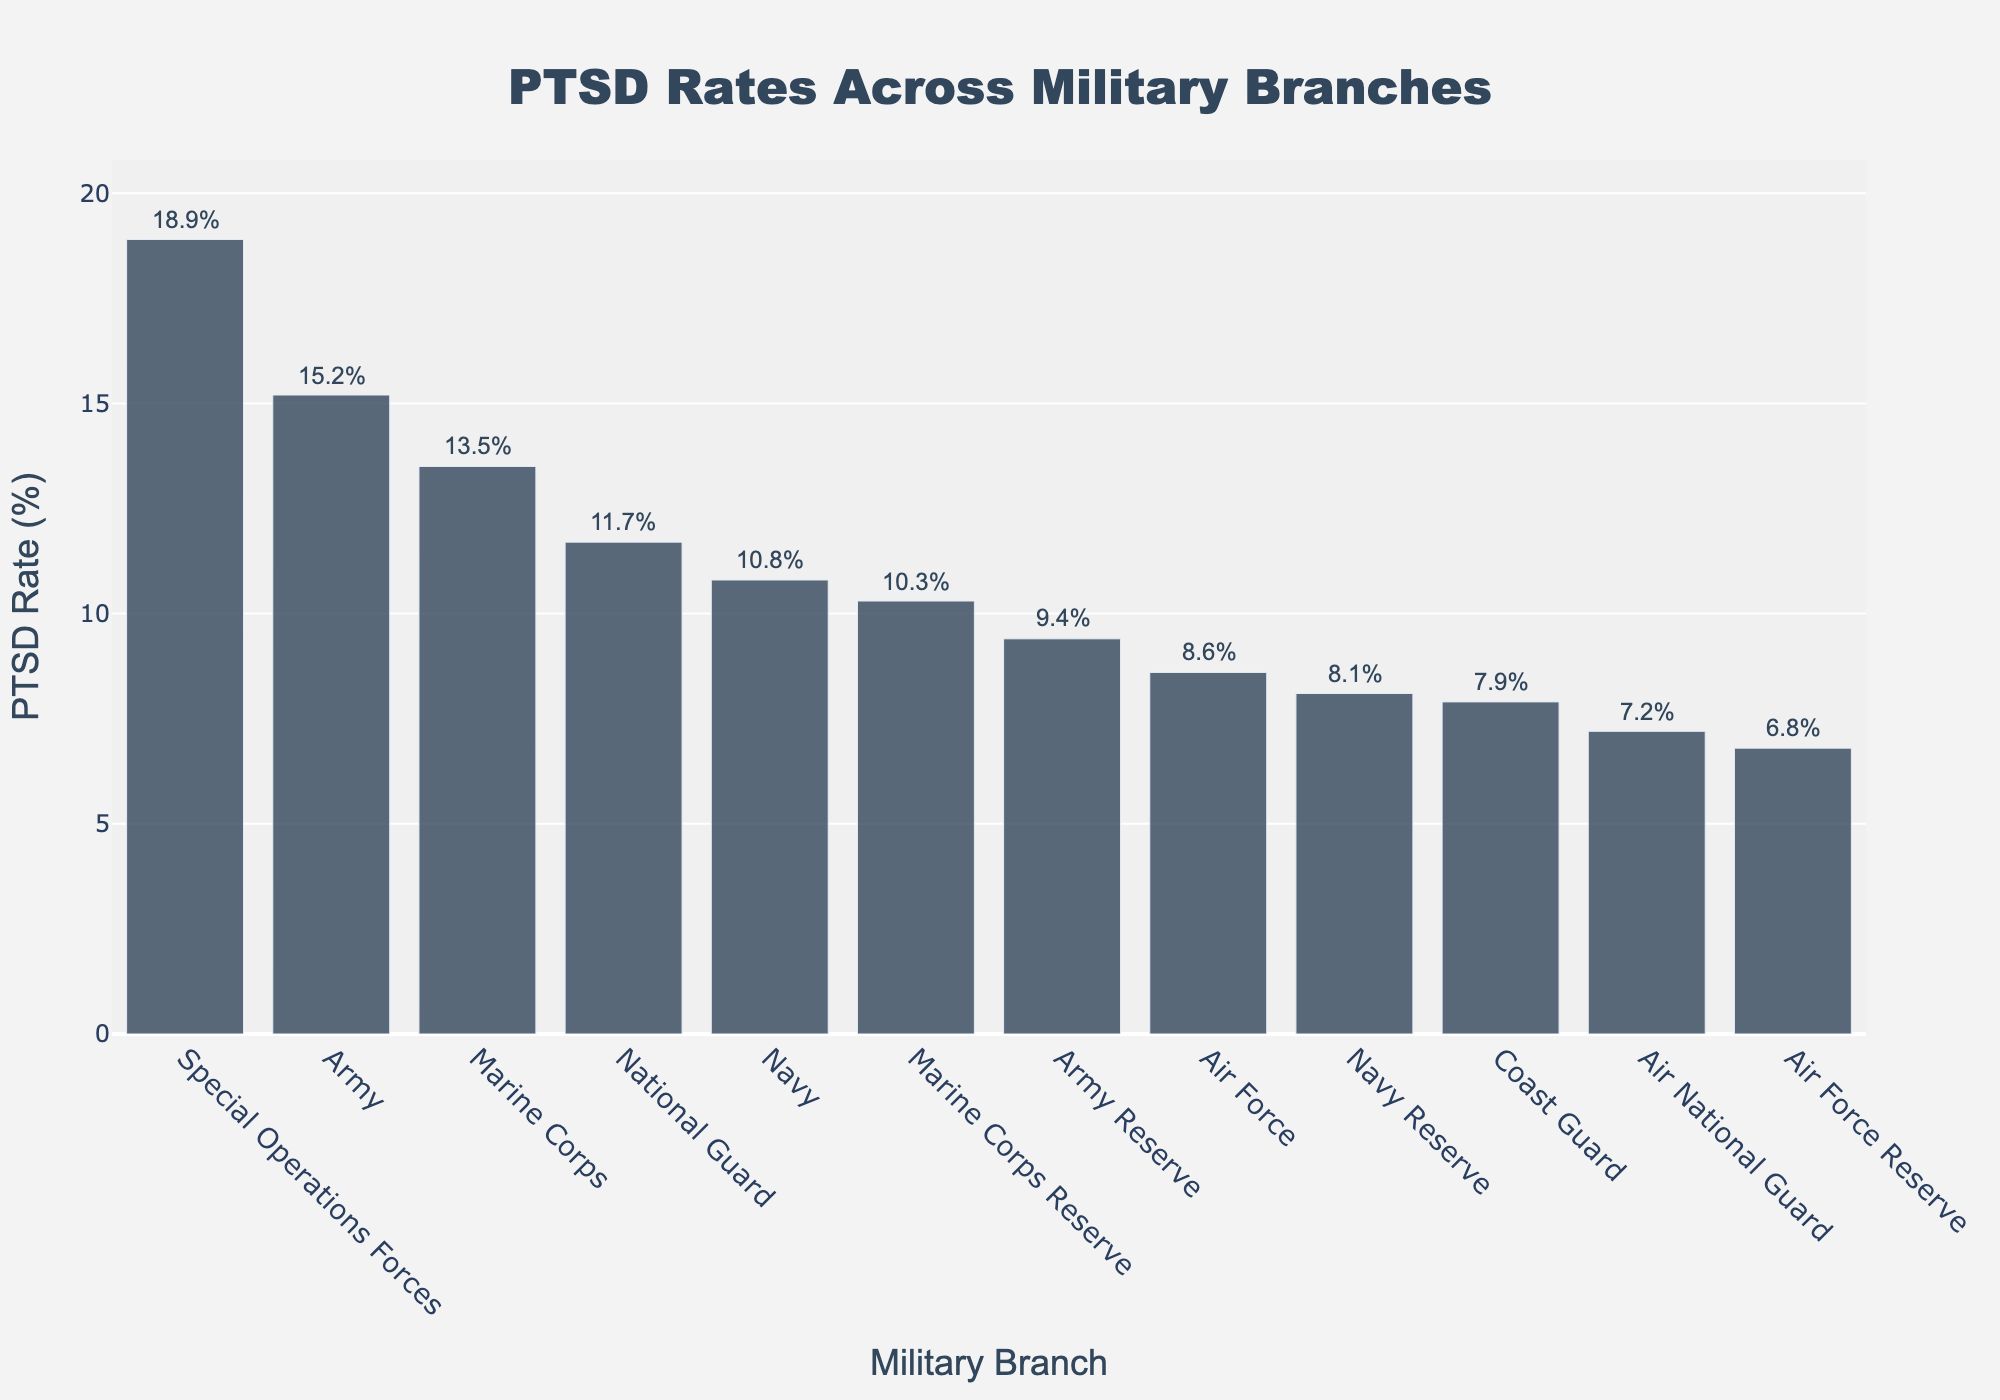Which military branch has the highest PTSD rate? The figure shows bar heights corresponding to PTSD rates. The tallest bar represents the branch with the highest PTSD rate. Here, the Special Operations Forces have the highest bar, indicating the highest PTSD rate.
Answer: Special Operations Forces Which branch has a lower PTSD rate: the Marine Corps Reserve or the Army Reserve? By comparing the bar heights, the Army Reserve's bar is shorter than the Marine Corps Reserve's bar. Thus, the Army Reserve has a lower PTSD rate.
Answer: Army Reserve What is the difference in PTSD rates between the Army and the Navy? Check the bars for the Army and the Navy. The Army's PTSD rate is 15.2%, and the Navy's PTSD rate is 10.8%. The difference is 15.2% - 10.8%.
Answer: 4.4% What is the average PTSD rate of the Army, Marine Corps, and Special Operations Forces? Add the PTSD rates of the Army (15.2%), Marine Corps (13.5%), and Special Operations Forces (18.9%), then divide by 3. (15.2 + 13.5 + 18.9) / 3 = 15.87%.
Answer: 15.87% How many branches have a PTSD rate greater than 10%? Identify and count the bars corresponding to branches with PTSD rates above 10%: Army, Marine Corps, Special Operations Forces, National Guard, Navy Reserve, Marine Corps Reserve, and Navy.
Answer: 7 Which branch has the closest PTSD rate to the median among all branches? First, order the branches by their PTSD rates and find the middle value. The median in this sorted list appears at the 6th and 7th positions: National Guard (11.7%) and Army Reserve (9.4%). Among them, the National Guard (11.7%) is closer to the middle of the sorted list.
Answer: National Guard What is the combined PTSD rate for all Reserve branches? Sum the PTSD rates of Army Reserve (9.4%), Navy Reserve (8.1%), Marine Corps Reserve (10.3%), and Air Force Reserve (6.8%). Total is 9.4 + 8.1 + 10.3 + 6.8 = 34.6%.
Answer: 34.6% Which branch has a PTSD rate closest to 10%? Looking at the bars, compare the rates to 10%. The Navy Reserve shows a PTSD rate of 10.3%, which is closest to 10%.
Answer: Navy Reserve What is the range of PTSD rates across all branches? Identify the highest and lowest PTSD rates. Special Operations Forces have the highest at 18.9%, and Air Force Reserve has the lowest at 6.8%. The range is 18.9% - 6.8%.
Answer: 12.1% What is the visual pattern of PTSD rates in Reserve branches compared to their corresponding active-duty counterparts? Notice the heights of bars for Reserve branches and their active-duty counterparts. Generally, Reserve branches like the Marine Corps Reserve (10.3%) and Navy Reserve (8.1%) have lower PTSD rates compared to their active-duty counterparts Marine Corps (13.5%) and Navy (10.8%), respectively.
Answer: Reserve branches generally have lower PTSD rates than active-duty counterparts 